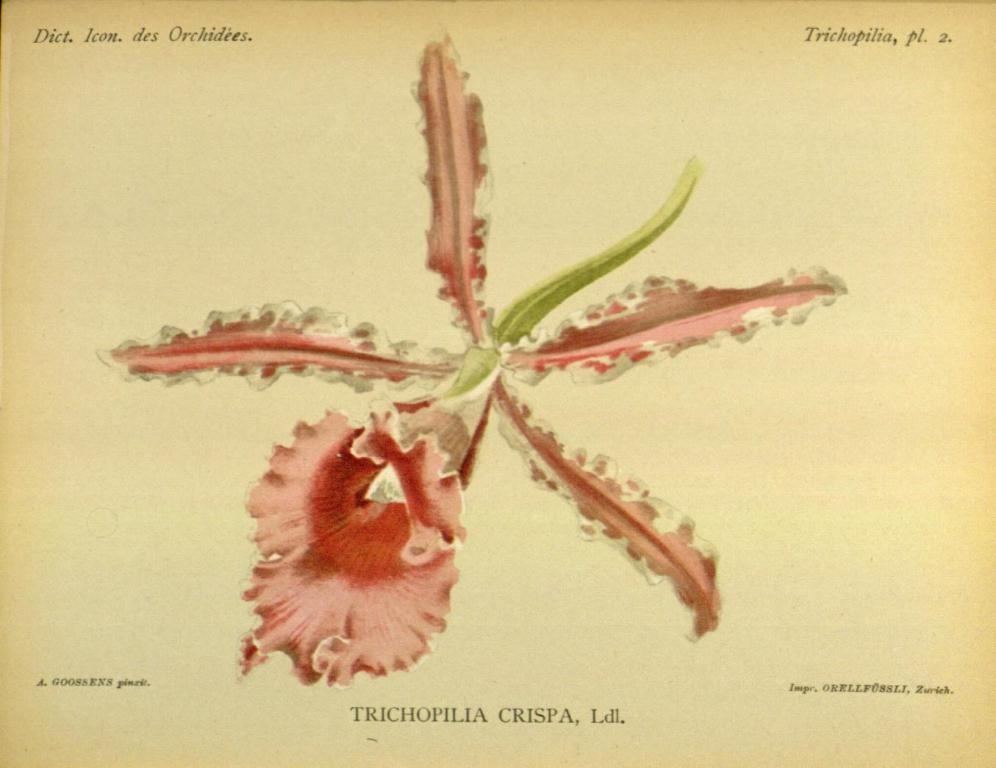What is the main subject of the image? The image contains a painting. What is depicted in the center of the painting? There is a flower with petals in the middle of the painting. Is there any text associated with the painting? Yes, there is some text at the bottom of the painting. How many baby snails can be seen crawling through the fog in the image? There is no fog, baby snails, or any crawling creatures present in the image. The image features a painting with a flower and text. 